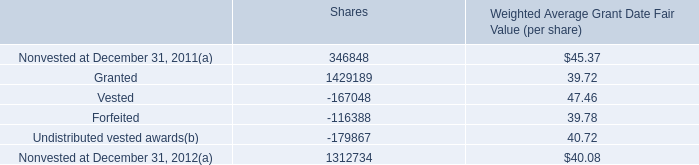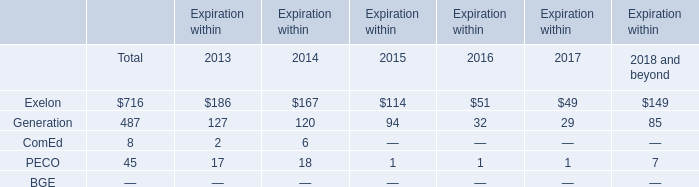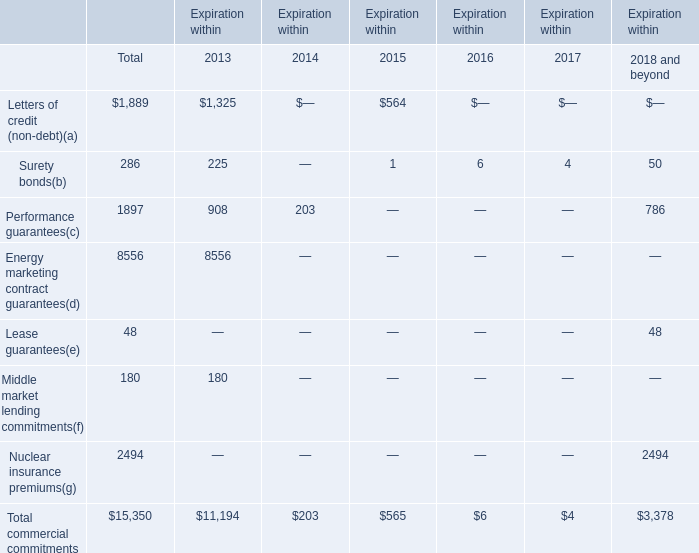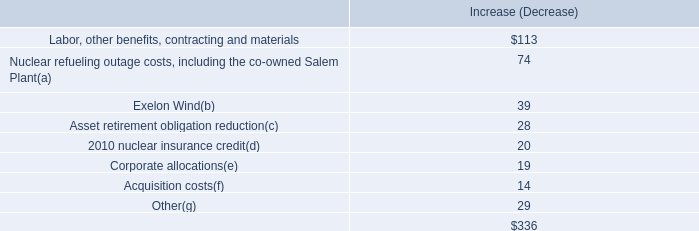What's the average of Undistributed vested awards of Shares, and Nuclear insurance premiums of Expiration within 2018 and beyond ? 
Computations: ((179867.0 + 2494.0) / 2)
Answer: 91180.5. 